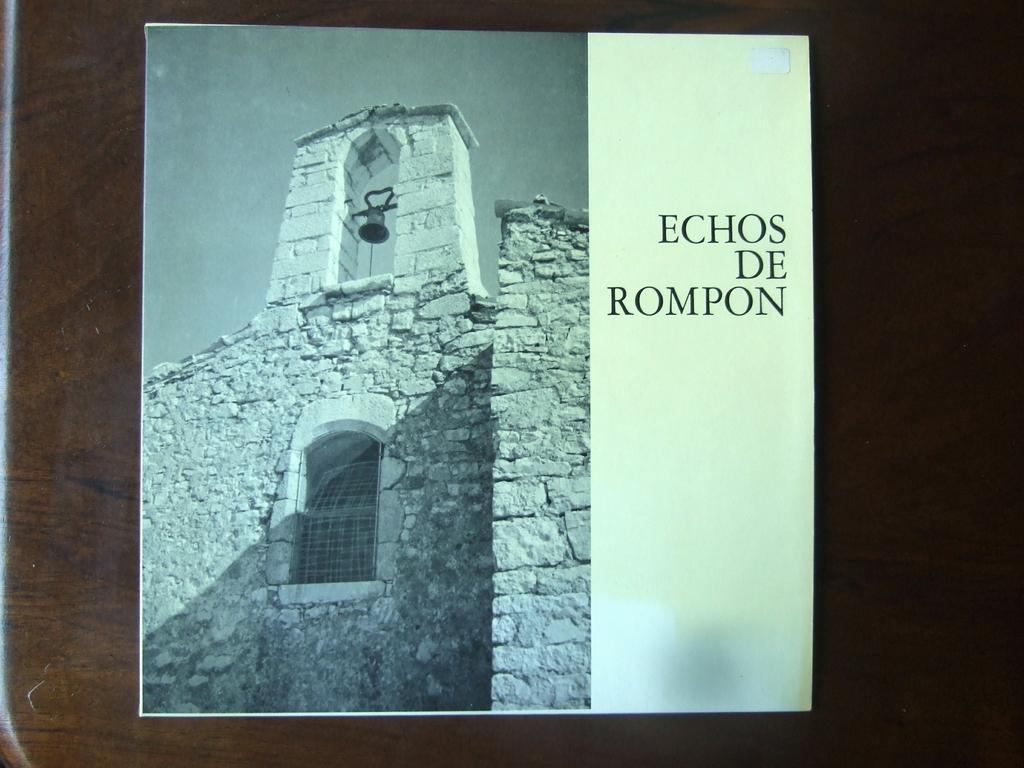<image>
Write a terse but informative summary of the picture. A record of Echos De Rompon is lying on a dark wooden surface. 